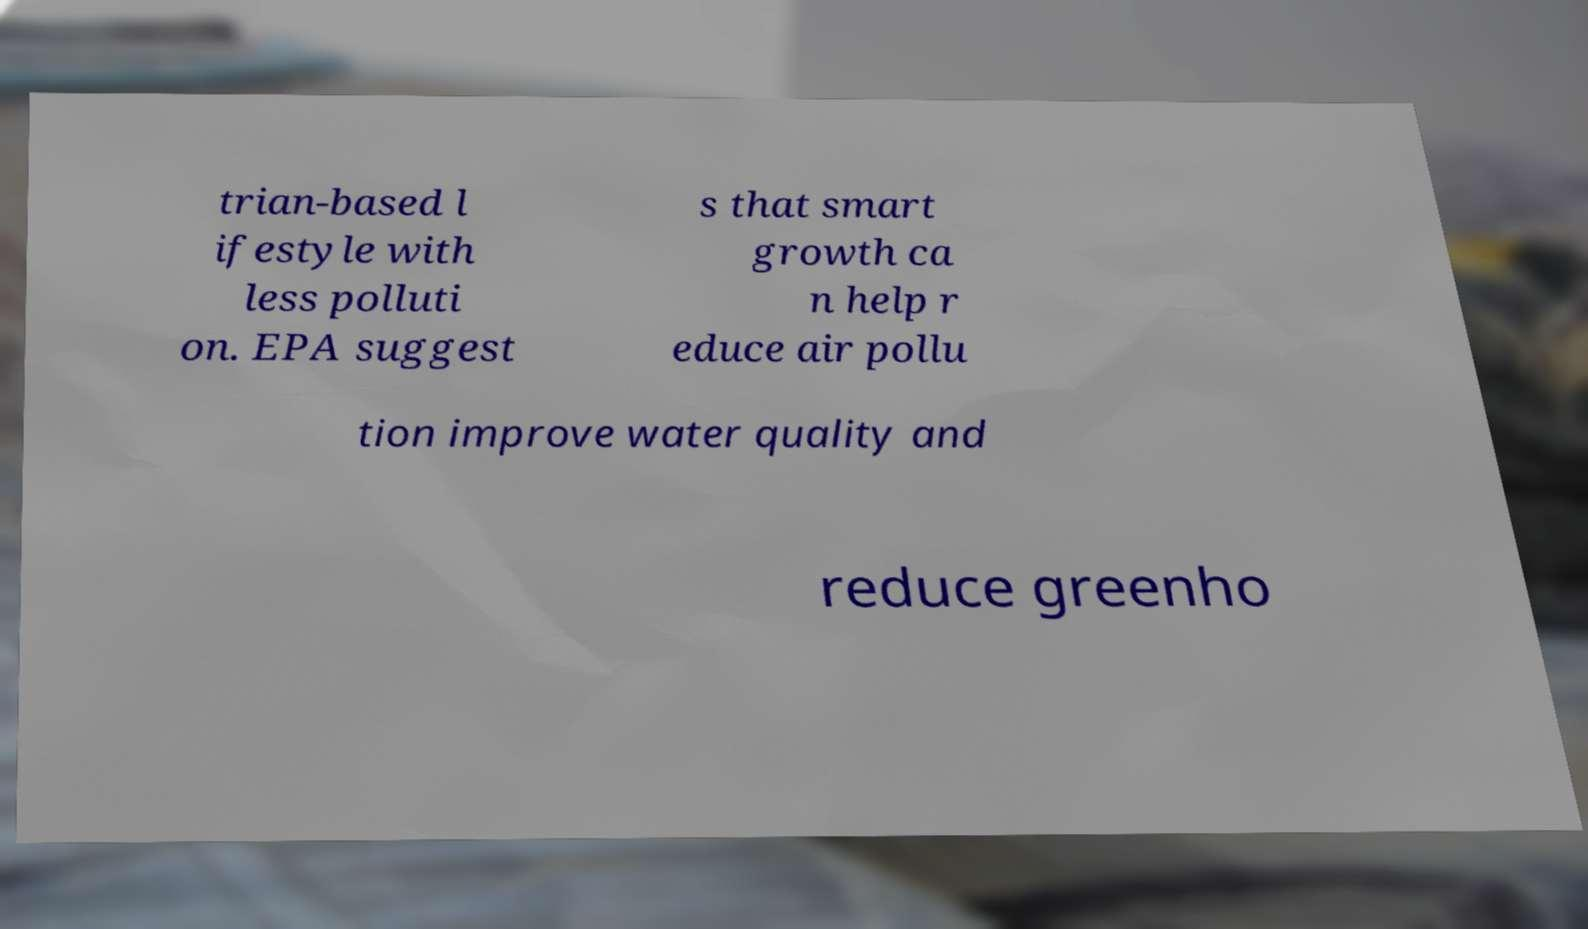Please identify and transcribe the text found in this image. trian-based l ifestyle with less polluti on. EPA suggest s that smart growth ca n help r educe air pollu tion improve water quality and reduce greenho 